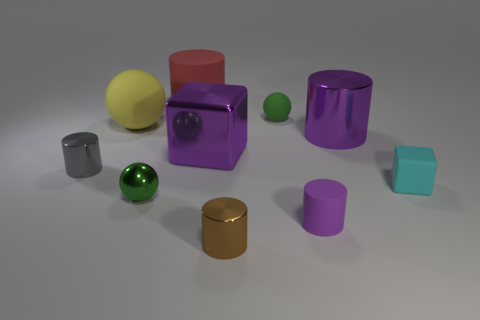There is a matte cylinder to the right of the big rubber object that is behind the green matte sphere; what color is it?
Your answer should be compact. Purple. There is a matte thing that is both right of the tiny brown shiny cylinder and behind the large yellow rubber thing; what is its size?
Offer a terse response. Small. How many other things are there of the same shape as the red object?
Make the answer very short. 4. There is a brown metallic object; does it have the same shape as the small green thing in front of the gray metal cylinder?
Offer a terse response. No. How many tiny objects are behind the tiny gray cylinder?
Ensure brevity in your answer.  1. Is there any other thing that is made of the same material as the big block?
Offer a very short reply. Yes. There is a purple object that is in front of the cyan rubber thing; is it the same shape as the tiny cyan thing?
Provide a short and direct response. No. There is a block to the right of the big cube; what color is it?
Ensure brevity in your answer.  Cyan. What shape is the gray thing that is the same material as the purple cube?
Make the answer very short. Cylinder. Is there any other thing that has the same color as the big block?
Give a very brief answer. Yes. 